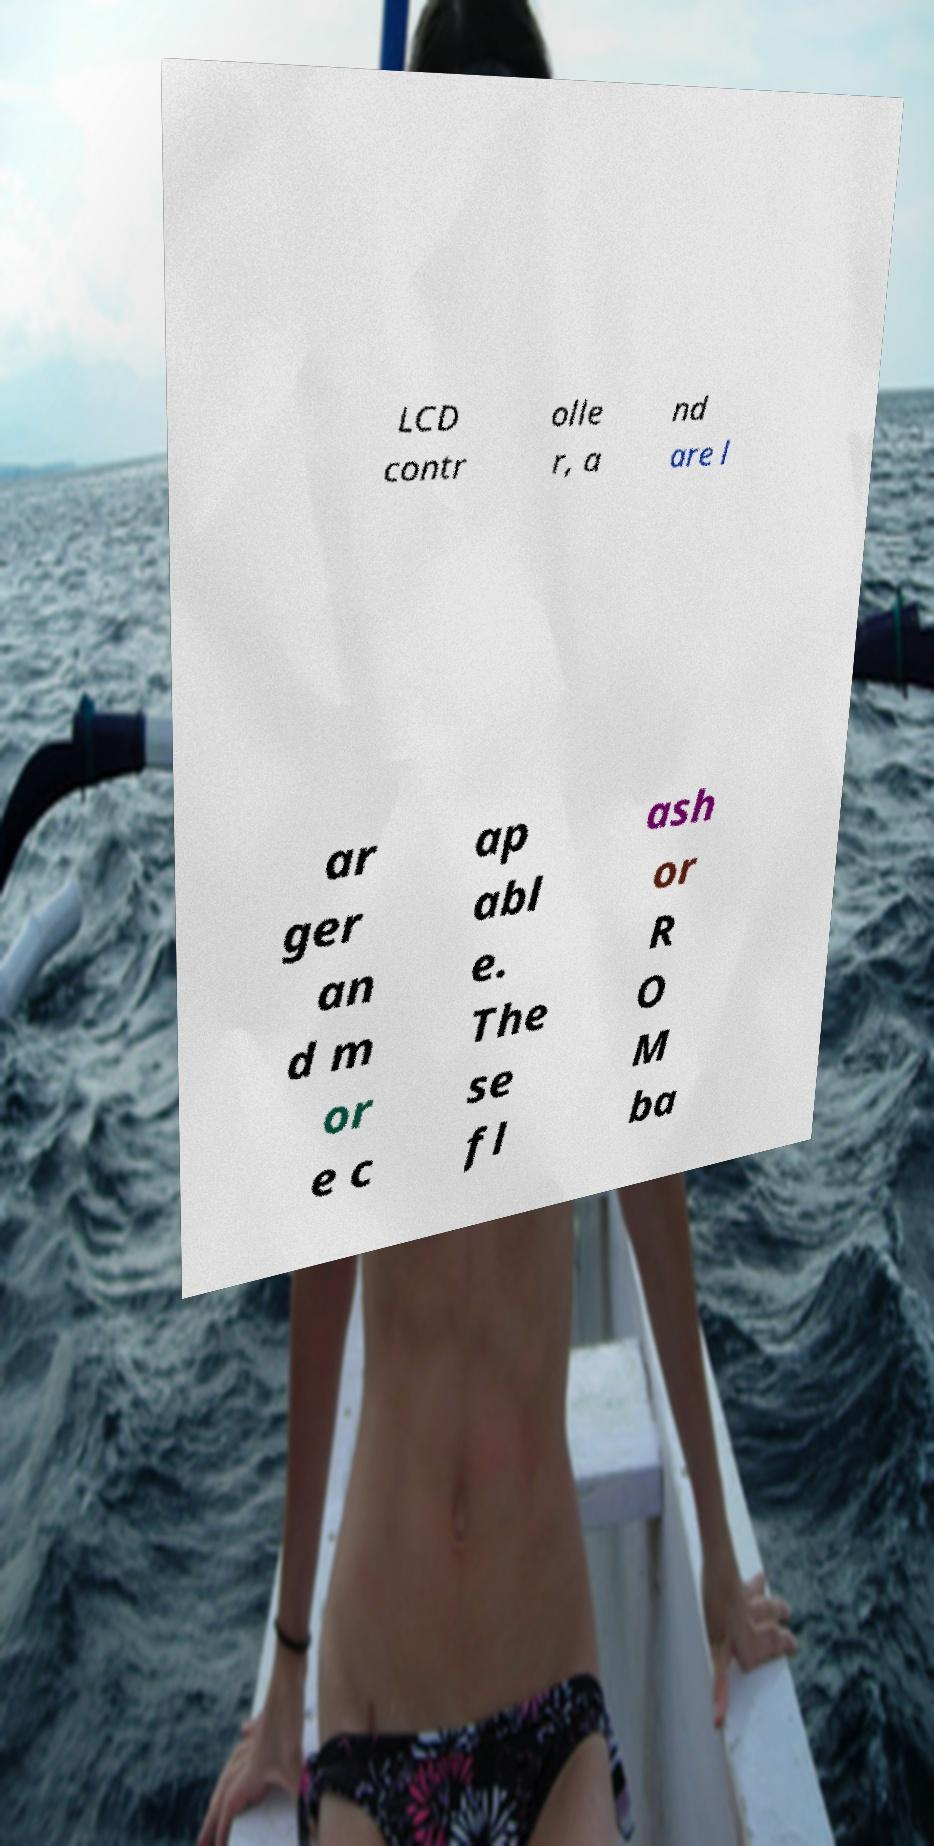Could you assist in decoding the text presented in this image and type it out clearly? LCD contr olle r, a nd are l ar ger an d m or e c ap abl e. The se fl ash or R O M ba 